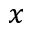<formula> <loc_0><loc_0><loc_500><loc_500>x</formula> 